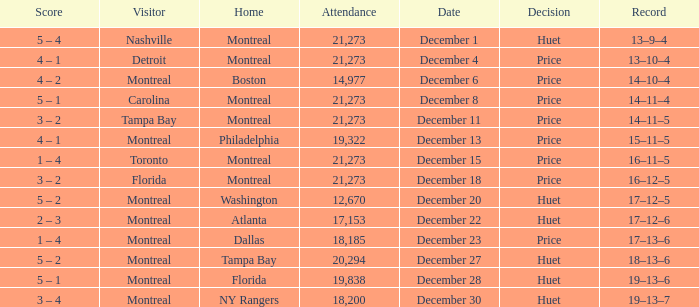What is the record on December 4? 13–10–4. 